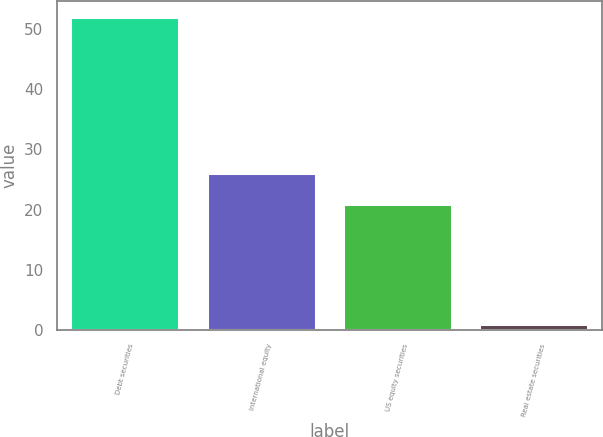Convert chart. <chart><loc_0><loc_0><loc_500><loc_500><bar_chart><fcel>Debt securities<fcel>International equity<fcel>US equity securities<fcel>Real estate securities<nl><fcel>52<fcel>26.1<fcel>21<fcel>1<nl></chart> 